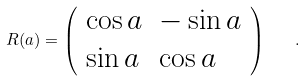<formula> <loc_0><loc_0><loc_500><loc_500>R ( a ) = \left ( \begin{array} { l l } { \cos a } & { - \sin a } \\ { \sin a } & { \cos a } \end{array} \right ) \quad .</formula> 